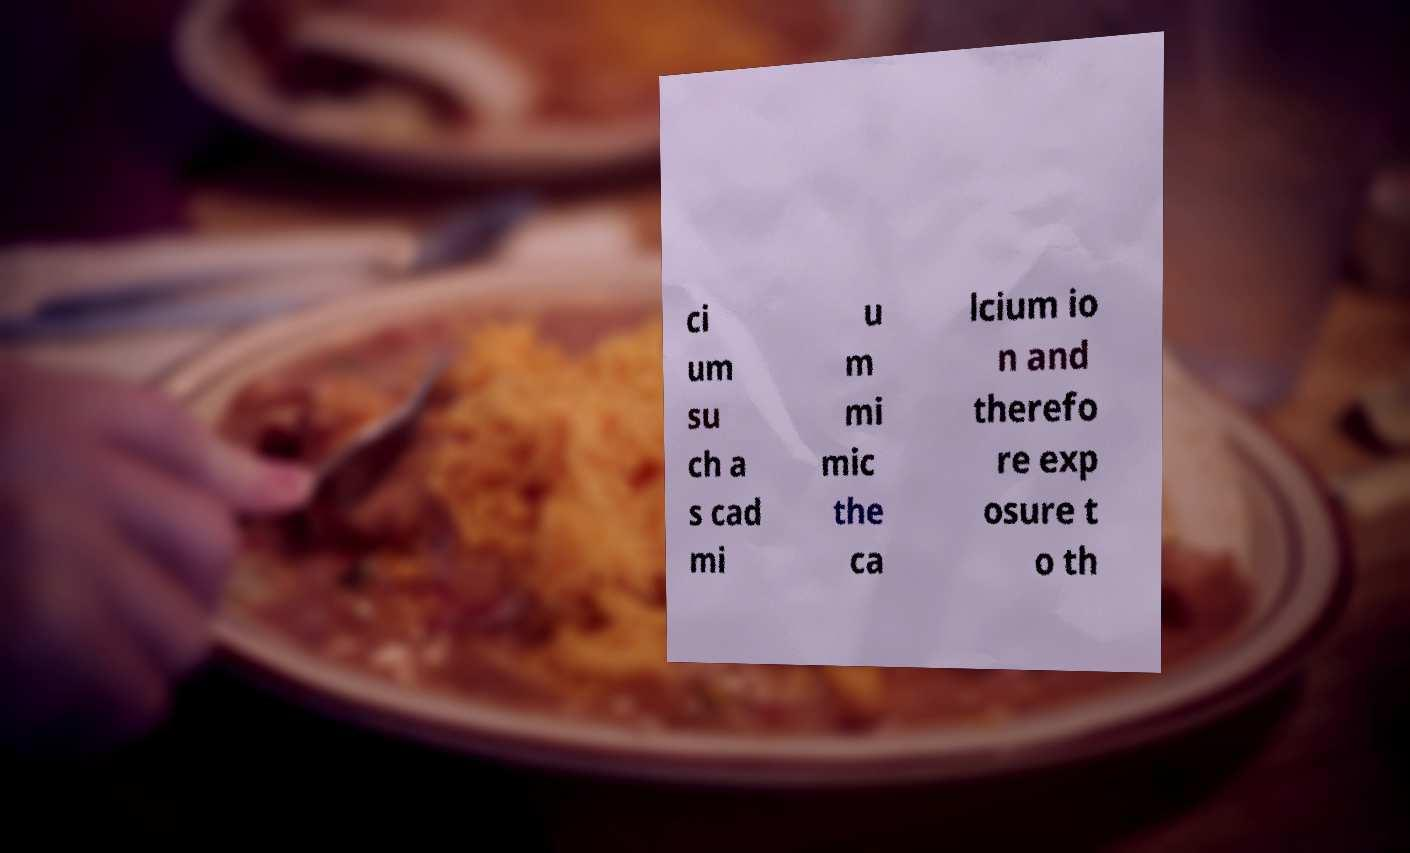I need the written content from this picture converted into text. Can you do that? ci um su ch a s cad mi u m mi mic the ca lcium io n and therefo re exp osure t o th 